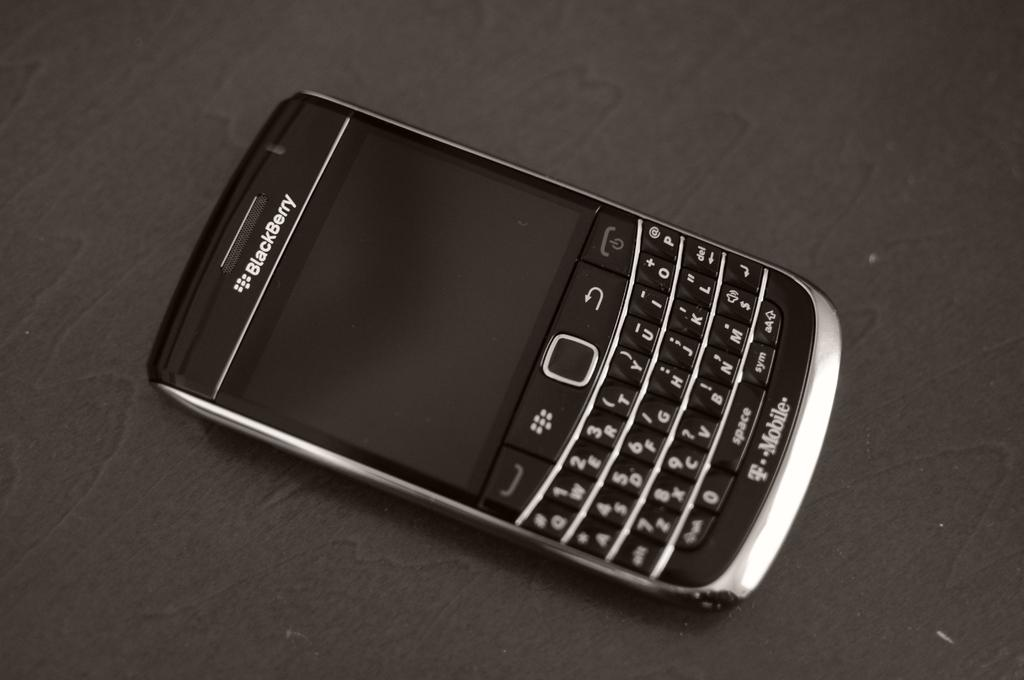<image>
Write a terse but informative summary of the picture. A Blackberry device is from the T-Mobile company. 